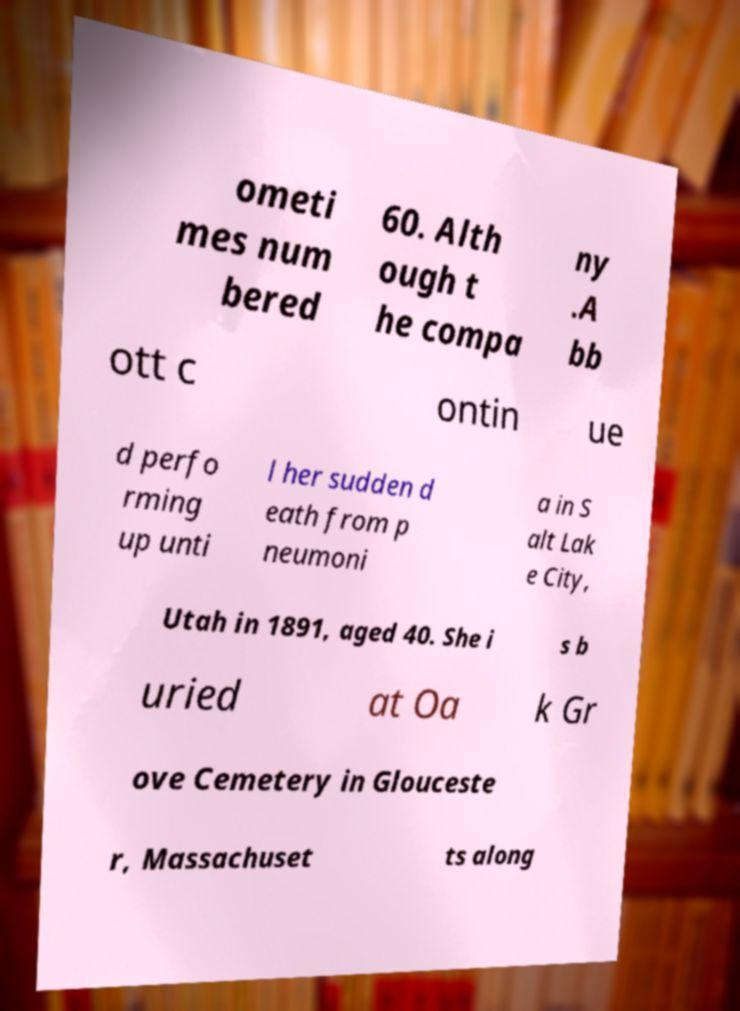There's text embedded in this image that I need extracted. Can you transcribe it verbatim? ometi mes num bered 60. Alth ough t he compa ny .A bb ott c ontin ue d perfo rming up unti l her sudden d eath from p neumoni a in S alt Lak e City, Utah in 1891, aged 40. She i s b uried at Oa k Gr ove Cemetery in Glouceste r, Massachuset ts along 